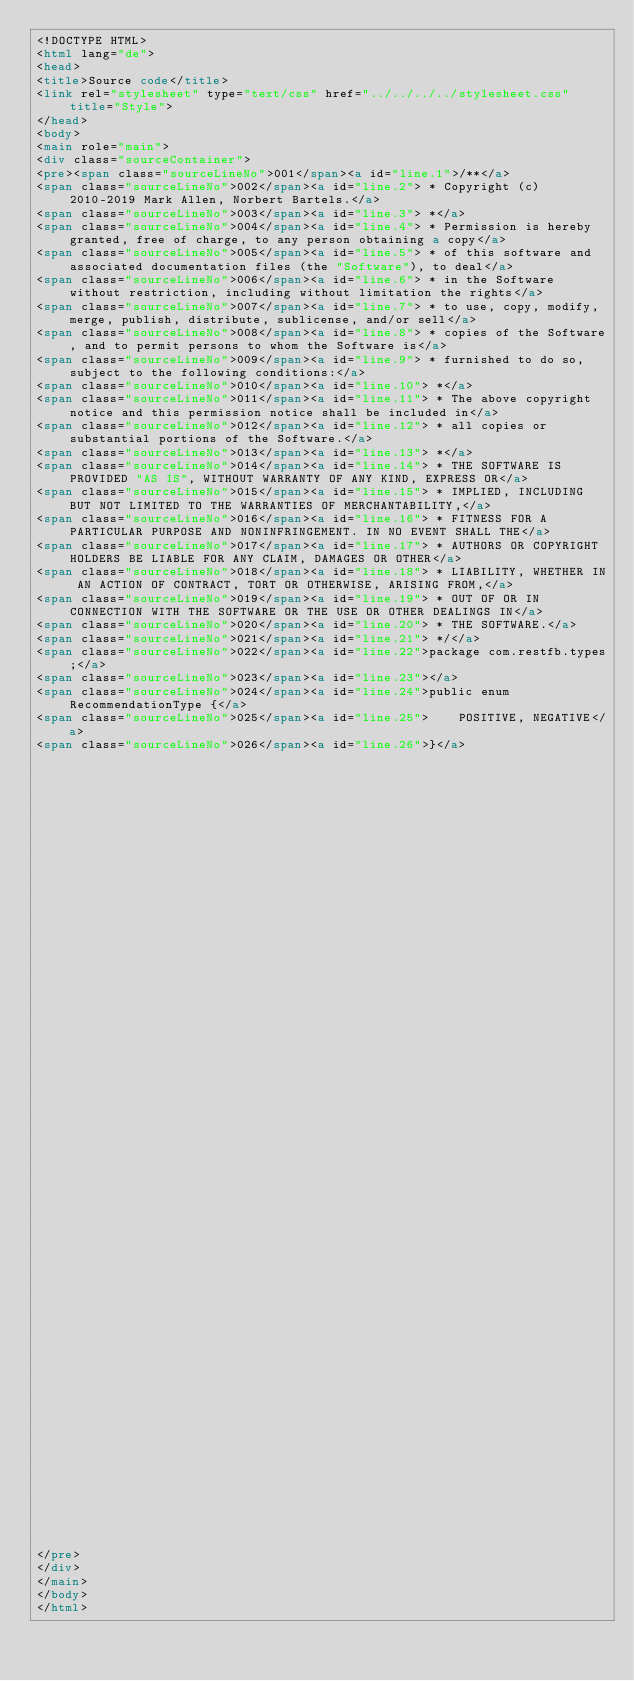Convert code to text. <code><loc_0><loc_0><loc_500><loc_500><_HTML_><!DOCTYPE HTML>
<html lang="de">
<head>
<title>Source code</title>
<link rel="stylesheet" type="text/css" href="../../../../stylesheet.css" title="Style">
</head>
<body>
<main role="main">
<div class="sourceContainer">
<pre><span class="sourceLineNo">001</span><a id="line.1">/**</a>
<span class="sourceLineNo">002</span><a id="line.2"> * Copyright (c) 2010-2019 Mark Allen, Norbert Bartels.</a>
<span class="sourceLineNo">003</span><a id="line.3"> *</a>
<span class="sourceLineNo">004</span><a id="line.4"> * Permission is hereby granted, free of charge, to any person obtaining a copy</a>
<span class="sourceLineNo">005</span><a id="line.5"> * of this software and associated documentation files (the "Software"), to deal</a>
<span class="sourceLineNo">006</span><a id="line.6"> * in the Software without restriction, including without limitation the rights</a>
<span class="sourceLineNo">007</span><a id="line.7"> * to use, copy, modify, merge, publish, distribute, sublicense, and/or sell</a>
<span class="sourceLineNo">008</span><a id="line.8"> * copies of the Software, and to permit persons to whom the Software is</a>
<span class="sourceLineNo">009</span><a id="line.9"> * furnished to do so, subject to the following conditions:</a>
<span class="sourceLineNo">010</span><a id="line.10"> *</a>
<span class="sourceLineNo">011</span><a id="line.11"> * The above copyright notice and this permission notice shall be included in</a>
<span class="sourceLineNo">012</span><a id="line.12"> * all copies or substantial portions of the Software.</a>
<span class="sourceLineNo">013</span><a id="line.13"> *</a>
<span class="sourceLineNo">014</span><a id="line.14"> * THE SOFTWARE IS PROVIDED "AS IS", WITHOUT WARRANTY OF ANY KIND, EXPRESS OR</a>
<span class="sourceLineNo">015</span><a id="line.15"> * IMPLIED, INCLUDING BUT NOT LIMITED TO THE WARRANTIES OF MERCHANTABILITY,</a>
<span class="sourceLineNo">016</span><a id="line.16"> * FITNESS FOR A PARTICULAR PURPOSE AND NONINFRINGEMENT. IN NO EVENT SHALL THE</a>
<span class="sourceLineNo">017</span><a id="line.17"> * AUTHORS OR COPYRIGHT HOLDERS BE LIABLE FOR ANY CLAIM, DAMAGES OR OTHER</a>
<span class="sourceLineNo">018</span><a id="line.18"> * LIABILITY, WHETHER IN AN ACTION OF CONTRACT, TORT OR OTHERWISE, ARISING FROM,</a>
<span class="sourceLineNo">019</span><a id="line.19"> * OUT OF OR IN CONNECTION WITH THE SOFTWARE OR THE USE OR OTHER DEALINGS IN</a>
<span class="sourceLineNo">020</span><a id="line.20"> * THE SOFTWARE.</a>
<span class="sourceLineNo">021</span><a id="line.21"> */</a>
<span class="sourceLineNo">022</span><a id="line.22">package com.restfb.types;</a>
<span class="sourceLineNo">023</span><a id="line.23"></a>
<span class="sourceLineNo">024</span><a id="line.24">public enum RecommendationType {</a>
<span class="sourceLineNo">025</span><a id="line.25">    POSITIVE, NEGATIVE</a>
<span class="sourceLineNo">026</span><a id="line.26">}</a>




























































</pre>
</div>
</main>
</body>
</html>
</code> 